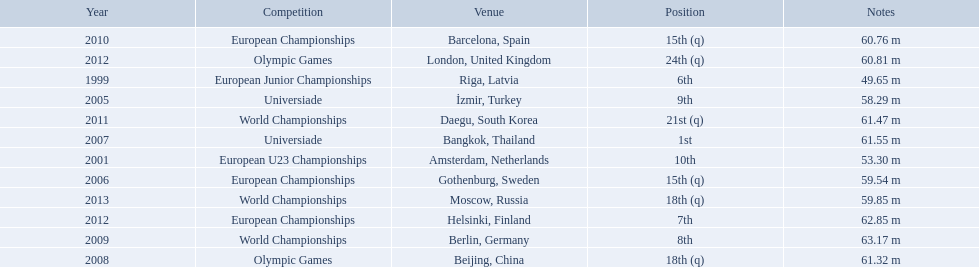Which competitions has gerhard mayer competed in since 1999? European Junior Championships, European U23 Championships, Universiade, European Championships, Universiade, Olympic Games, World Championships, European Championships, World Championships, European Championships, Olympic Games, World Championships. Of these competition, in which ones did he throw at least 60 m? Universiade, Olympic Games, World Championships, European Championships, World Championships, European Championships, Olympic Games. Of these throws, which was his longest? 63.17 m. 